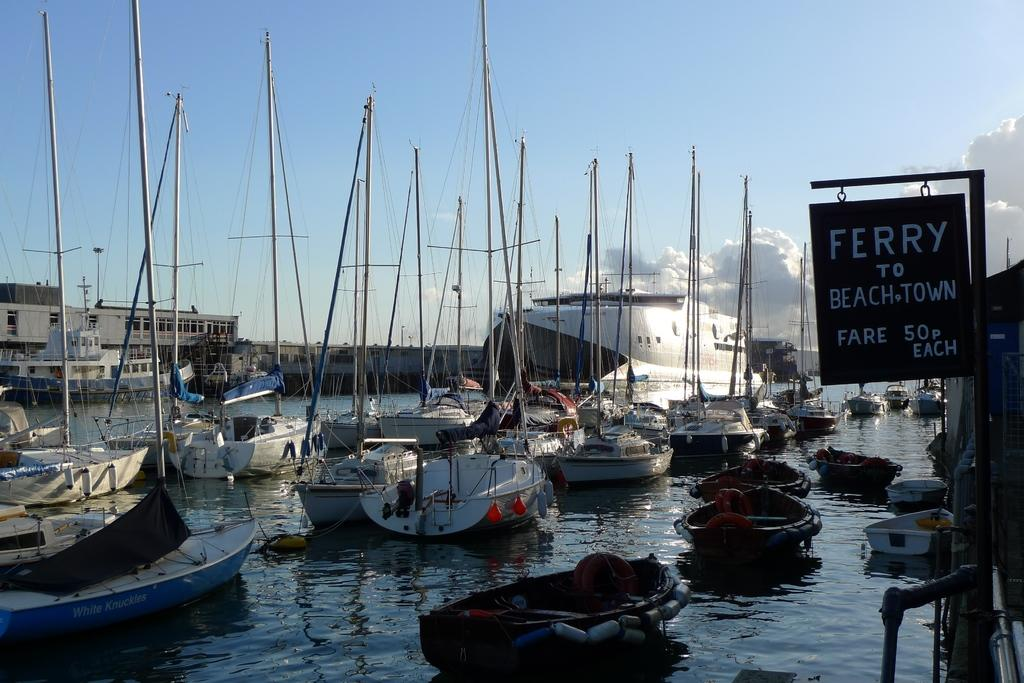<image>
Create a compact narrative representing the image presented. Many boats at a marina in the water by the Ferry 